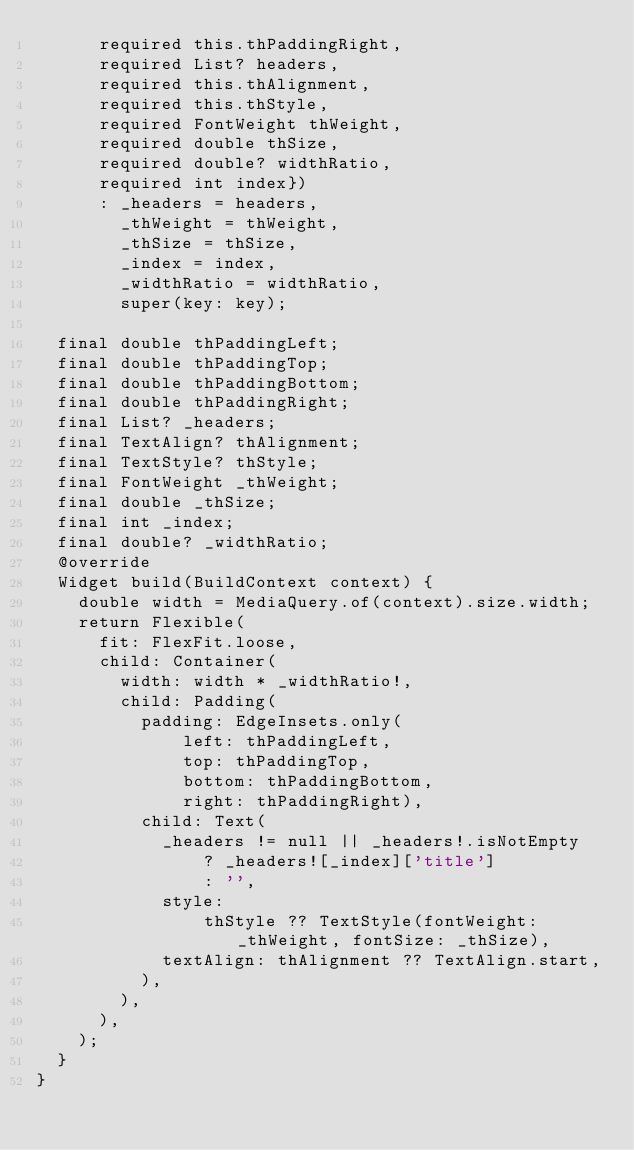Convert code to text. <code><loc_0><loc_0><loc_500><loc_500><_Dart_>      required this.thPaddingRight,
      required List? headers,
      required this.thAlignment,
      required this.thStyle,
      required FontWeight thWeight,
      required double thSize,
      required double? widthRatio,
      required int index})
      : _headers = headers,
        _thWeight = thWeight,
        _thSize = thSize,
        _index = index,
        _widthRatio = widthRatio,
        super(key: key);

  final double thPaddingLeft;
  final double thPaddingTop;
  final double thPaddingBottom;
  final double thPaddingRight;
  final List? _headers;
  final TextAlign? thAlignment;
  final TextStyle? thStyle;
  final FontWeight _thWeight;
  final double _thSize;
  final int _index;
  final double? _widthRatio;
  @override
  Widget build(BuildContext context) {
    double width = MediaQuery.of(context).size.width;
    return Flexible(
      fit: FlexFit.loose,
      child: Container(
        width: width * _widthRatio!,
        child: Padding(
          padding: EdgeInsets.only(
              left: thPaddingLeft,
              top: thPaddingTop,
              bottom: thPaddingBottom,
              right: thPaddingRight),
          child: Text(
            _headers != null || _headers!.isNotEmpty
                ? _headers![_index]['title']
                : '',
            style:
                thStyle ?? TextStyle(fontWeight: _thWeight, fontSize: _thSize),
            textAlign: thAlignment ?? TextAlign.start,
          ),
        ),
      ),
    );
  }
}
</code> 